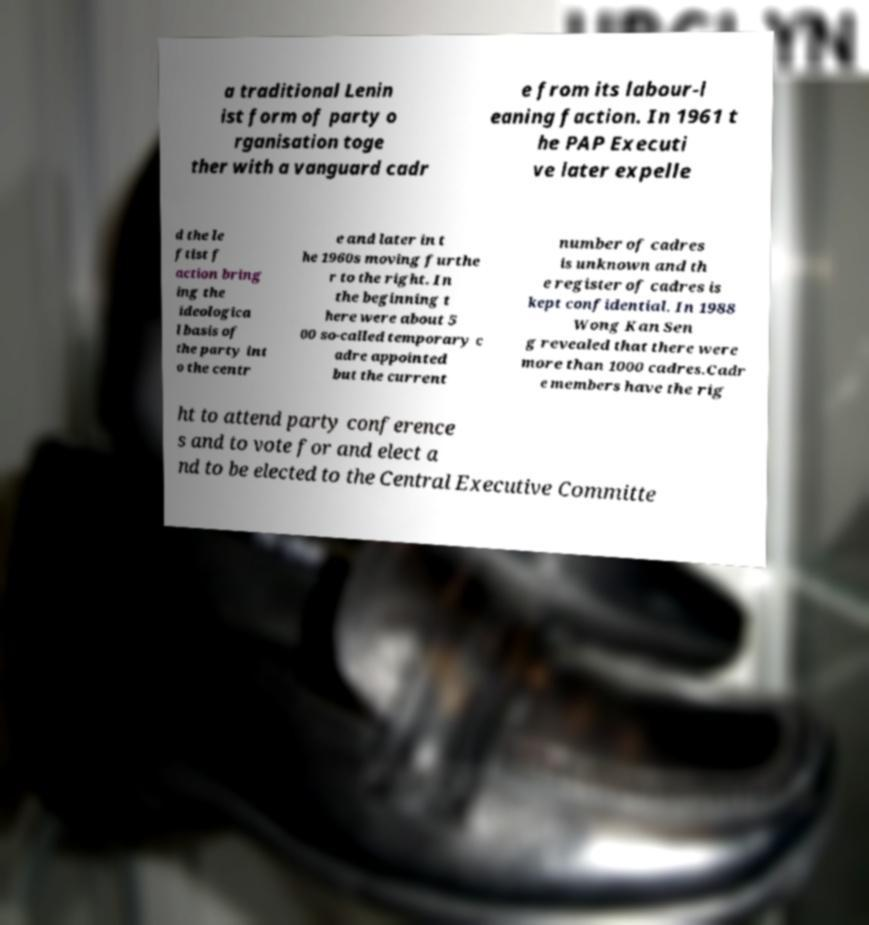What messages or text are displayed in this image? I need them in a readable, typed format. a traditional Lenin ist form of party o rganisation toge ther with a vanguard cadr e from its labour-l eaning faction. In 1961 t he PAP Executi ve later expelle d the le ftist f action bring ing the ideologica l basis of the party int o the centr e and later in t he 1960s moving furthe r to the right. In the beginning t here were about 5 00 so-called temporary c adre appointed but the current number of cadres is unknown and th e register of cadres is kept confidential. In 1988 Wong Kan Sen g revealed that there were more than 1000 cadres.Cadr e members have the rig ht to attend party conference s and to vote for and elect a nd to be elected to the Central Executive Committe 